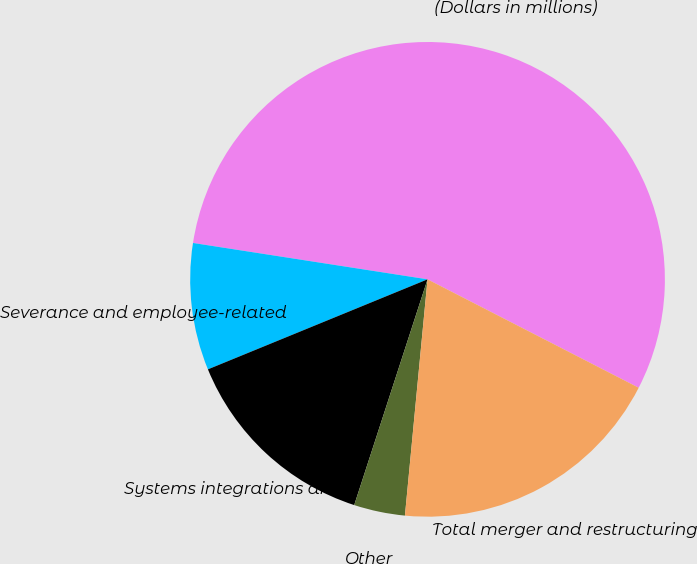<chart> <loc_0><loc_0><loc_500><loc_500><pie_chart><fcel>(Dollars in millions)<fcel>Severance and employee-related<fcel>Systems integrations and<fcel>Other<fcel>Total merger and restructuring<nl><fcel>55.1%<fcel>8.64%<fcel>13.81%<fcel>3.48%<fcel>18.97%<nl></chart> 